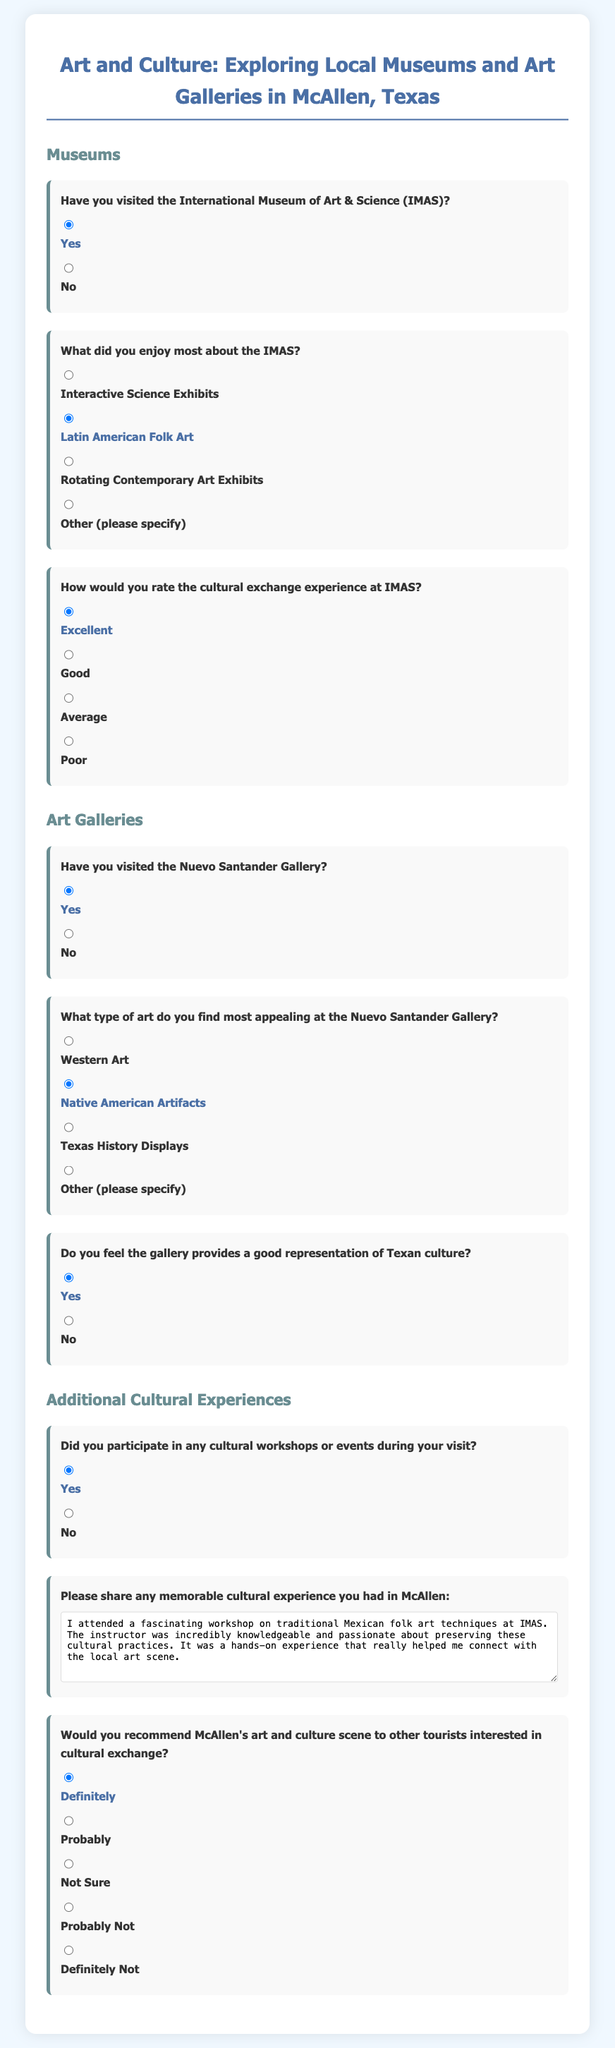Have you visited the International Museum of Art & Science (IMAS)? The question asks if the participant has been to IMAS, which is answered by a yes or no option in the document.
Answer: Yes What did you enjoy most about the IMAS? This question seeks to identify what aspect of IMAS the participant liked the most, listed as options in the document.
Answer: Latin American Folk Art How would you rate the cultural exchange experience at IMAS? The document asks for a rating of the cultural experience, which has multiple choice options ranging from excellent to poor.
Answer: Excellent Have you visited the Nuevo Santander Gallery? This question checks if the participant has been to the Nuevo Santander Gallery, with a yes or no answer.
Answer: Yes What type of art do you find most appealing at the Nuevo Santander Gallery? The document lists different art types available at the gallery, and this question seeks to find out which one the participant prefers.
Answer: Native American Artifacts Do you feel the gallery provides a good representation of Texan culture? This queries the participant's opinion on the gallery's representation of Texan culture, providing yes and no options.
Answer: Yes Did you participate in any cultural workshops or events during your visit? This question inquires whether the participant partook in any cultural events, with a yes or no response available.
Answer: Yes Please share any memorable cultural experience you had in McAllen: The document includes a space for participants to describe a memorable cultural experience, asking for a brief recollection.
Answer: I attended a fascinating workshop on traditional Mexican folk art techniques at IMAS Would you recommend McAllen's art and culture scene to other tourists interested in cultural exchange? This question asks for a recommendation status regarding McAllen's cultural scene, with various answer options provided.
Answer: Definitely 